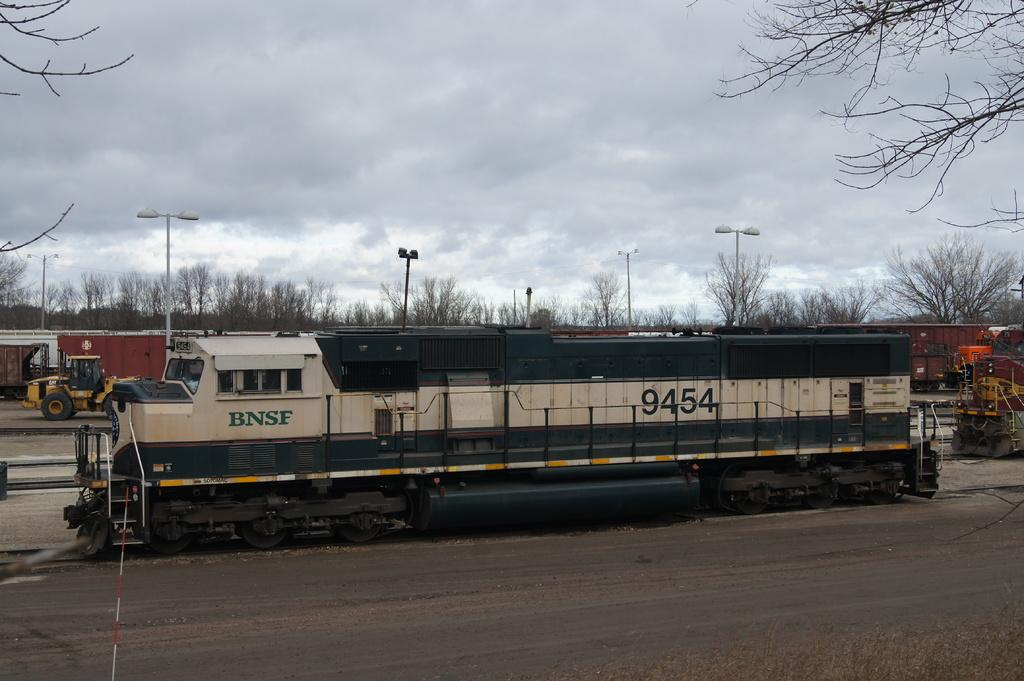What is the main subject of the image? The main subject of the image is a train. What is the train doing in the image? The train is moving on a railway track. What can be seen in the background of the image? In the background, there is a bulldozer, other trains, trees, light poles, and a cloudy sky. How much profit does the moon generate in the image? The moon is not present in the image, and therefore it cannot generate any profit. 